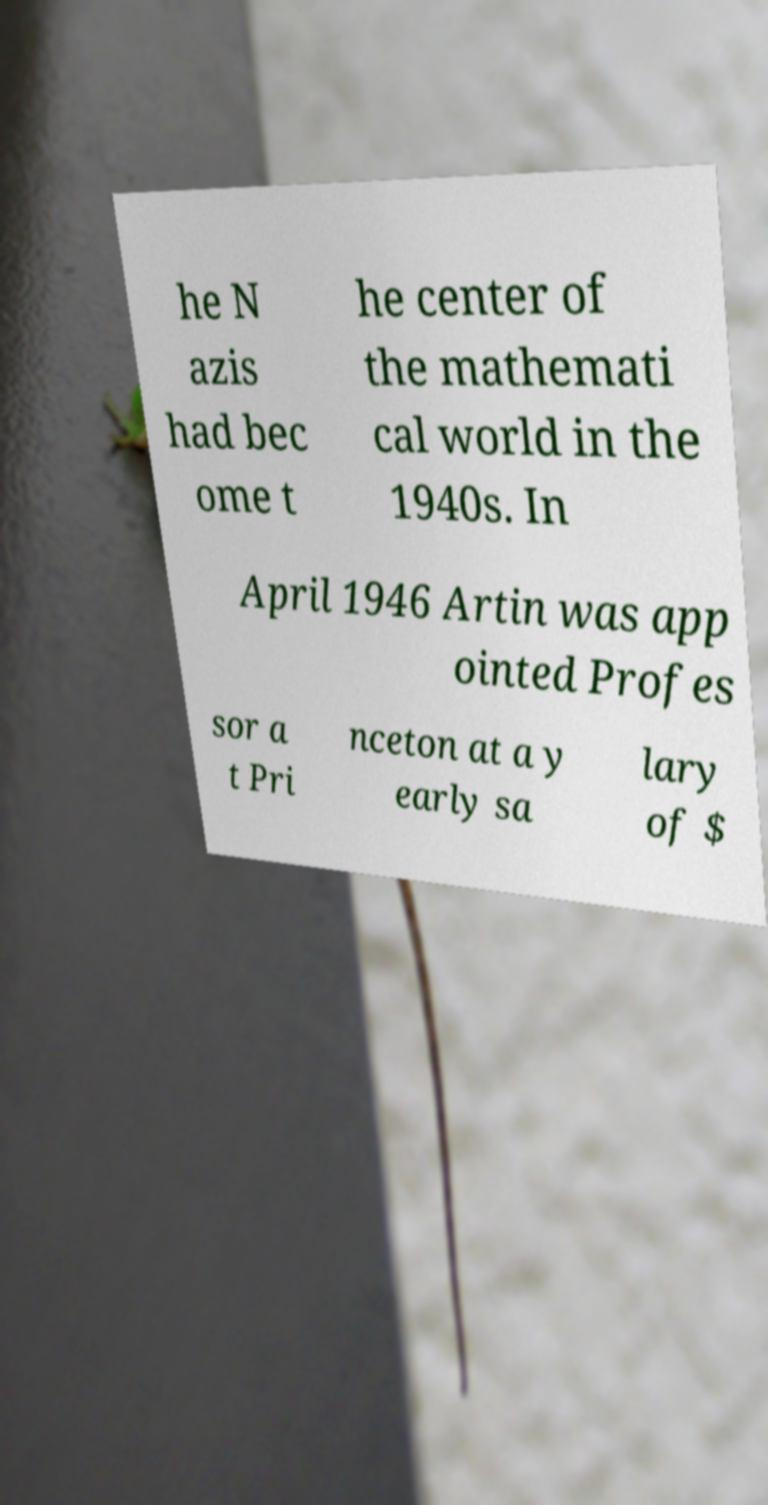For documentation purposes, I need the text within this image transcribed. Could you provide that? he N azis had bec ome t he center of the mathemati cal world in the 1940s. In April 1946 Artin was app ointed Profes sor a t Pri nceton at a y early sa lary of $ 